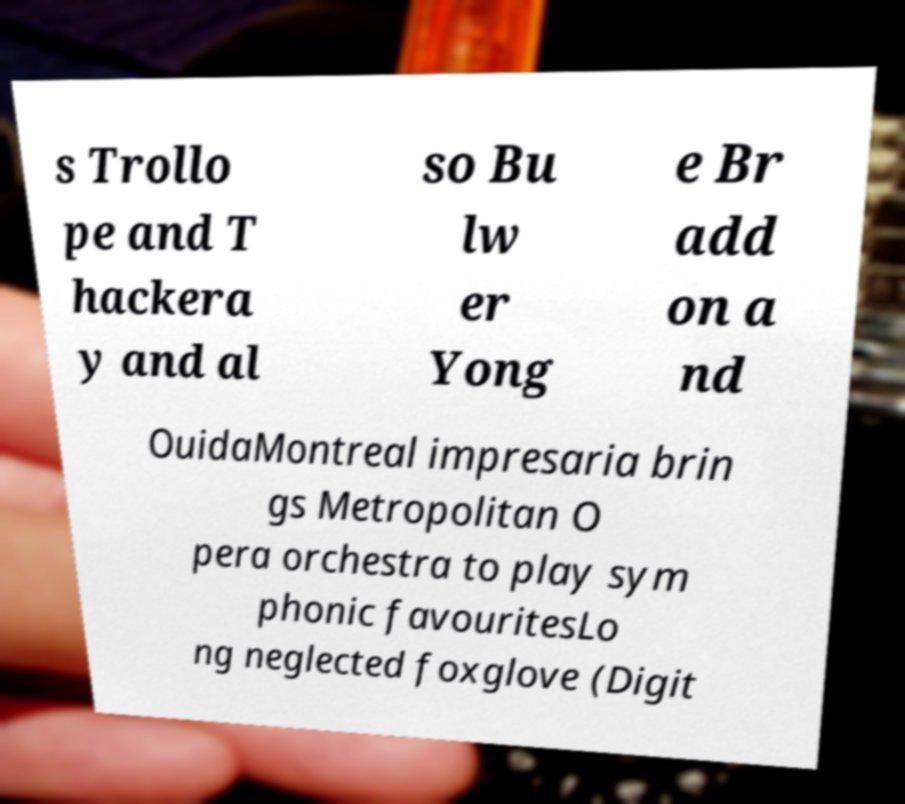I need the written content from this picture converted into text. Can you do that? s Trollo pe and T hackera y and al so Bu lw er Yong e Br add on a nd OuidaMontreal impresaria brin gs Metropolitan O pera orchestra to play sym phonic favouritesLo ng neglected foxglove (Digit 